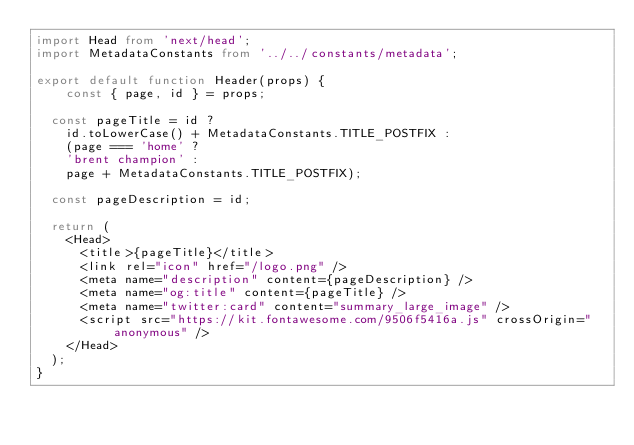<code> <loc_0><loc_0><loc_500><loc_500><_TypeScript_>import Head from 'next/head';
import MetadataConstants from '../../constants/metadata';

export default function Header(props) {
    const { page, id } = props;

	const pageTitle = id ? 
		id.toLowerCase() + MetadataConstants.TITLE_POSTFIX : 
		(page === 'home' ? 
		'brent champion' : 
		page + MetadataConstants.TITLE_POSTFIX);
		
	const pageDescription = id;

	return (
		<Head>
			<title>{pageTitle}</title>
			<link rel="icon" href="/logo.png" />
			<meta name="description" content={pageDescription} />
			<meta name="og:title" content={pageTitle} />
			<meta name="twitter:card" content="summary_large_image" />
			<script src="https://kit.fontawesome.com/9506f5416a.js" crossOrigin="anonymous" />
		</Head>
	);
}
</code> 